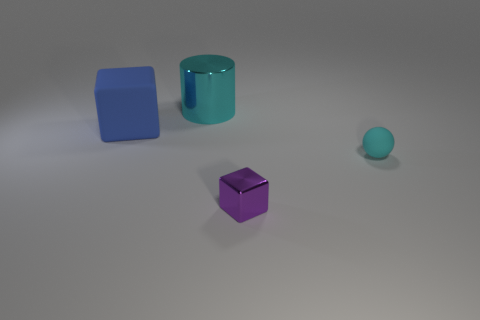Can you describe the scene composition and what it might convey? The composition features a collection of geometric shapes spaced apart on a flat surface. The varying sizes and positions could indicate a sense of order or balance. The cool color palette, combined with the minimalistic arrangement, might convey a serene or modern aesthetic. This set-up could be interpreted as an abstract representation of objects in space or a deliberate study of form and color. 